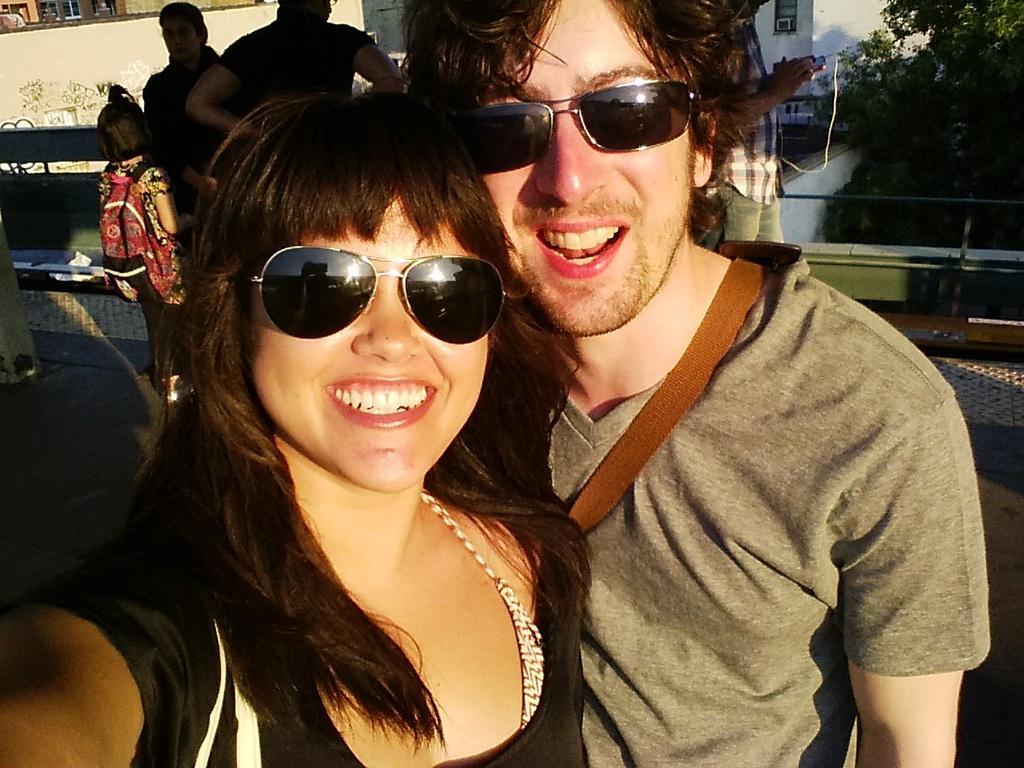Describe this image in one or two sentences. This image is taken outdoors. In the middle of the image a man and a woman are standing and they are with smiling faces. In the background there are a few houses and trees. There is a railing and a man is walking on the floor and holding a mobile phone in his hands. There is a kid and there are two persons. 